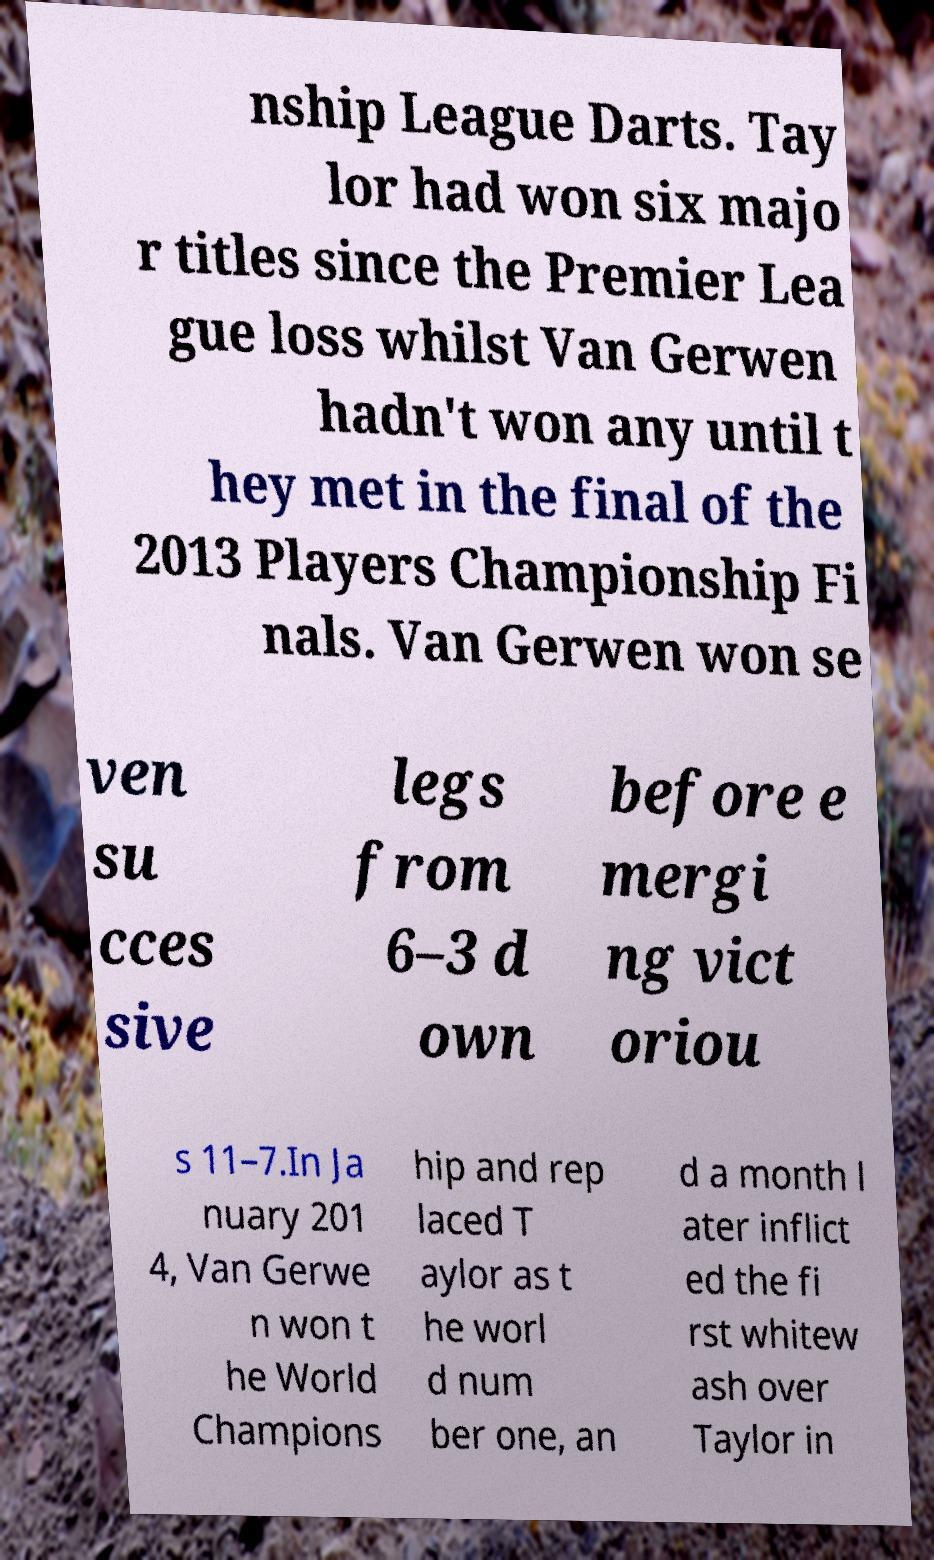Can you accurately transcribe the text from the provided image for me? nship League Darts. Tay lor had won six majo r titles since the Premier Lea gue loss whilst Van Gerwen hadn't won any until t hey met in the final of the 2013 Players Championship Fi nals. Van Gerwen won se ven su cces sive legs from 6–3 d own before e mergi ng vict oriou s 11–7.In Ja nuary 201 4, Van Gerwe n won t he World Champions hip and rep laced T aylor as t he worl d num ber one, an d a month l ater inflict ed the fi rst whitew ash over Taylor in 